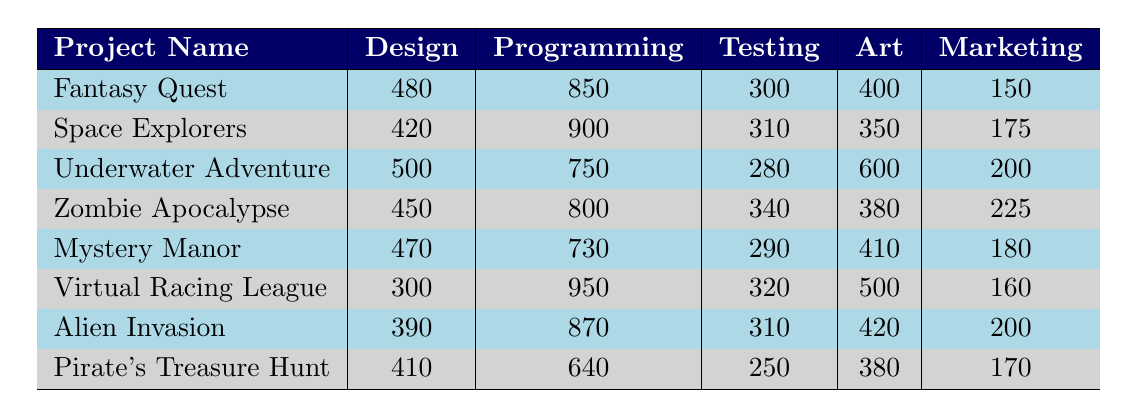What project had the highest marketing hours logged? Looking at the marketing hours for each project, "Zombie Apocalypse" has the highest value at 225 hours.
Answer: Zombie Apocalypse Which project required the most design hours? Upon reviewing the design hours for all projects, "Underwater Adventure" has the highest value at 500 hours.
Answer: Underwater Adventure What is the total programming hours for all projects? Adding up all the programming hours: 850 + 900 + 750 + 800 + 730 + 950 + 870 + 640 = 5720 hours in total.
Answer: 5720 Which project had the least testing hours? Reviewing the testing hours, "Pirate's Treasure Hunt" has the least with only 250 hours logged.
Answer: Pirate's Treasure Hunt Calculate the average art hours across all projects. Total art hours: 400 + 350 + 600 + 380 + 410 + 500 + 420 + 380 = 3,340 hours. There are 8 projects, so the average is 3,340 / 8 = 417.5 hours.
Answer: 417.5 Did any project have more than 900 programming hours? Yes, "Space Explorers" and "Virtual Racing League" both logged over 900 programming hours (900 and 950, respectively).
Answer: Yes Which project had the highest combination of design and programming hours? Calculating the sum of design and programming hours: "Virtual Racing League" has 300 + 950 = 1250, "Space Explorers" is 420 + 900 = 1320, "Fantasy Quest" is 480 + 850 = 1330, and "Underwater Adventure" is 500 + 750 = 1250. "Fantasy Quest" has the highest value at 1330 hours.
Answer: Fantasy Quest What is the difference between the highest and lowest marketing hours logged? The highest marketing hours are from "Zombie Apocalypse" with 225 hours and the lowest is "Fantasy Quest" with 150 hours, yielding a difference of 225 - 150 = 75 hours.
Answer: 75 What project had the second highest total of all hours logged (design + programming + testing + art + marketing)? Calculating the total hours for each project, "Space Explorers" had 420 + 900 + 310 + 350 + 175 = 2155, and "Fantasy Quest" had 480 + 850 + 300 + 400 + 150 = 2180. "Fantasy Quest" has the highest and "Space Explorers" is the second highest.
Answer: Space Explorers Is the total time spent on art across all projects greater than that for testing? Total art hours: 3,340 and total testing hours: 2,770, confirming that art hours surpassed testing hours.
Answer: Yes 